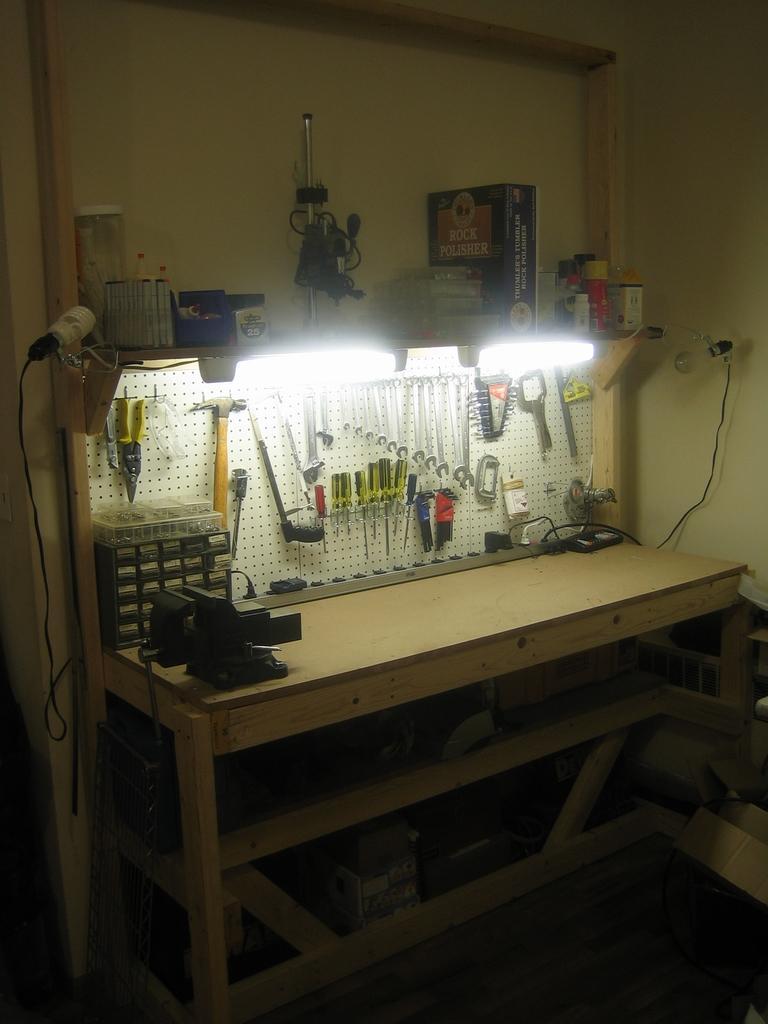Can you describe this image briefly? In this image we can see a wooden table on which we can see few objects are kept. Here we can see some tools hanged to the board, here and we can see the lights bulbs. 